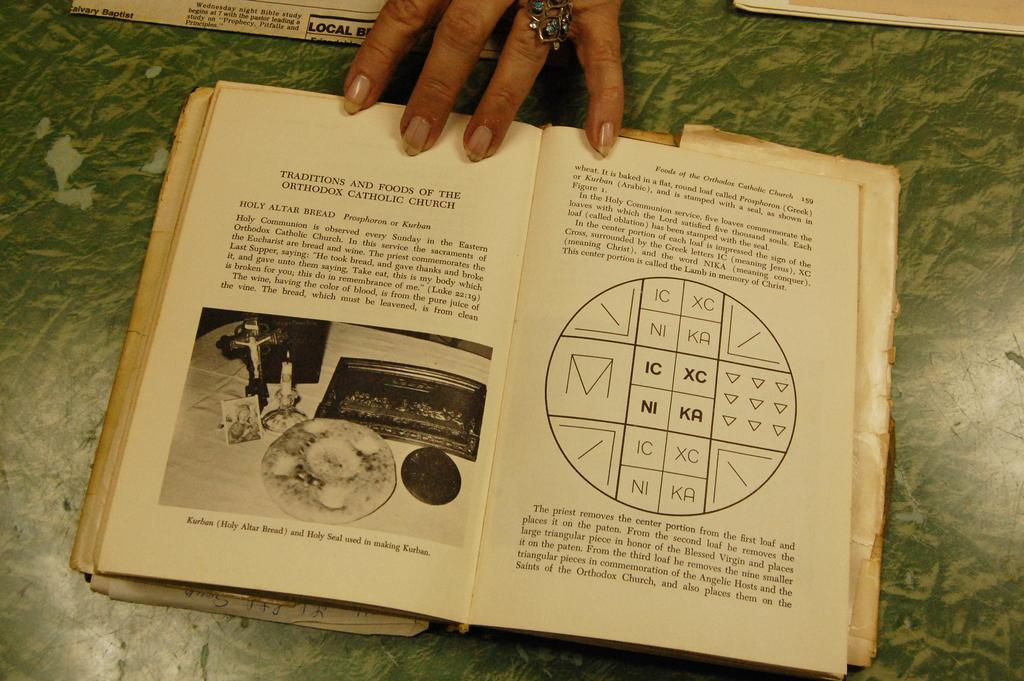Provide a one-sentence caption for the provided image. A opened book of food from a Catholic Church book. 